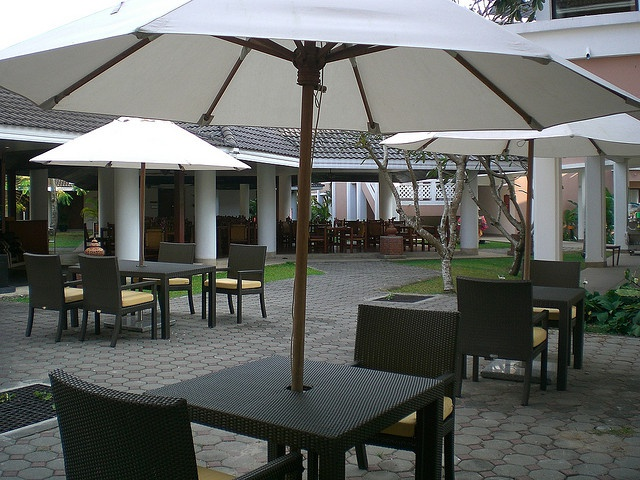Describe the objects in this image and their specific colors. I can see umbrella in white, darkgray, lavender, gray, and black tones, dining table in white, gray, black, and purple tones, chair in white, black, and gray tones, chair in white, black, gray, and olive tones, and umbrella in white, darkgray, black, and gray tones in this image. 